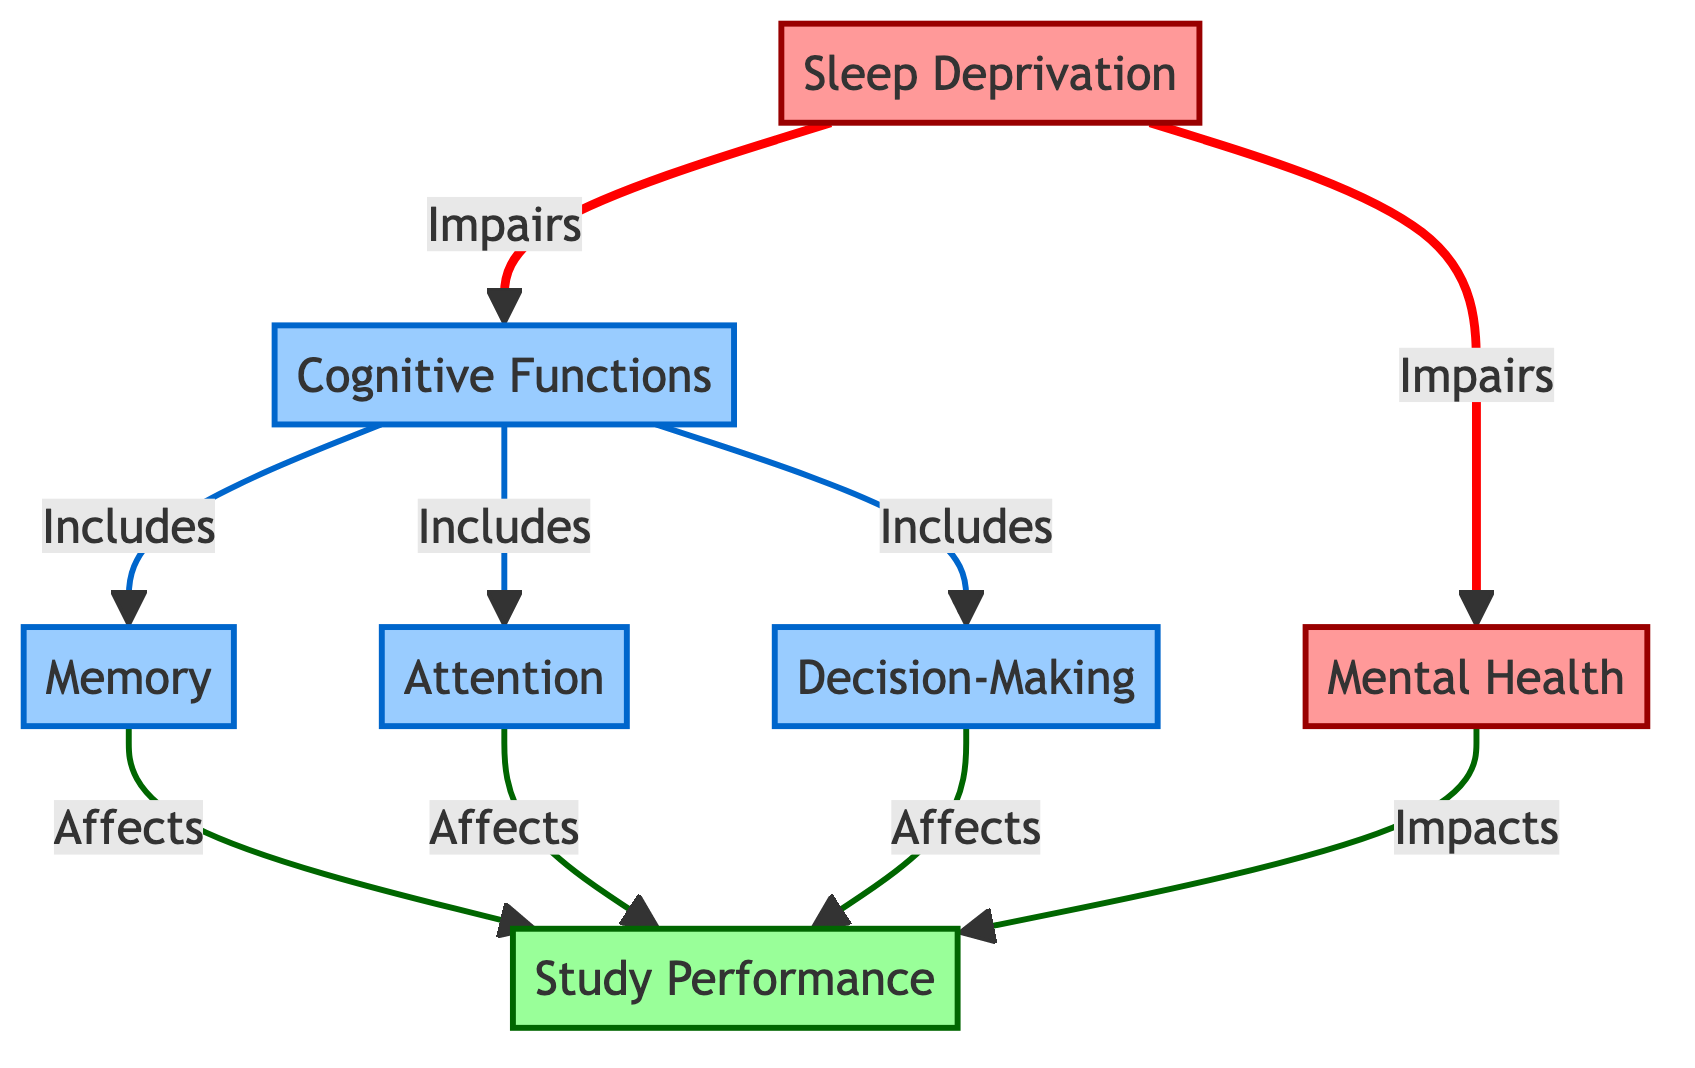What does sleep deprivation impair? The diagram explicitly states that sleep deprivation impairs cognitive functions and mental health, as indicated by the connections labeled "Impairs" leading to both cognitive functions and mental health.
Answer: cognitive functions, mental health How many cognitive functions are identified in the diagram? The diagram includes three specific cognitive functions directly linked to cognitive functions: memory, attention, and decision-making. Counting these nodes gives a total of three.
Answer: 3 What affects study performance according to the diagram? The diagram shows that both memory and attention directly affect study performance, as indicated by the arrows leading to study performance from these cognitive functions. Additionally, decision-making also affects study performance.
Answer: memory, attention, decision-making What is the relationship between mental health and study performance? The diagram indicates that mental health is impaired by sleep deprivation, and it also shows an arrow leading from mental health to study performance, indicating that mental health impacts study performance.
Answer: impacts Which node serves as a category for the elements within it? The node labeled "Cognitive Functions" serves as the category for the three elements under it: memory, attention, and decision-making, as indicated by the "Includes" arrows directing towards these nodes.
Answer: Cognitive Functions What color represents impaired nodes in the diagram? The color associated with impaired nodes in the diagram is represented by a light red hue (#ff9999) for sleep deprivation and mental health, as specified in the class definitions for the diagram.
Answer: light red How does attention relate to study performance? Attention is specifically linked to study performance within the diagram, indicated by an arrow that states that attention "Affects" study performance, showing the direct relationship between these two nodes.
Answer: Affects What impacts study performance after sleep deprivation? The diagram illustrates that both cognitive functions (memory, attention, and decision-making) and mental health are impacted after sleep deprivation which leads to the impairment of study performance.
Answer: cognitive functions, mental health 